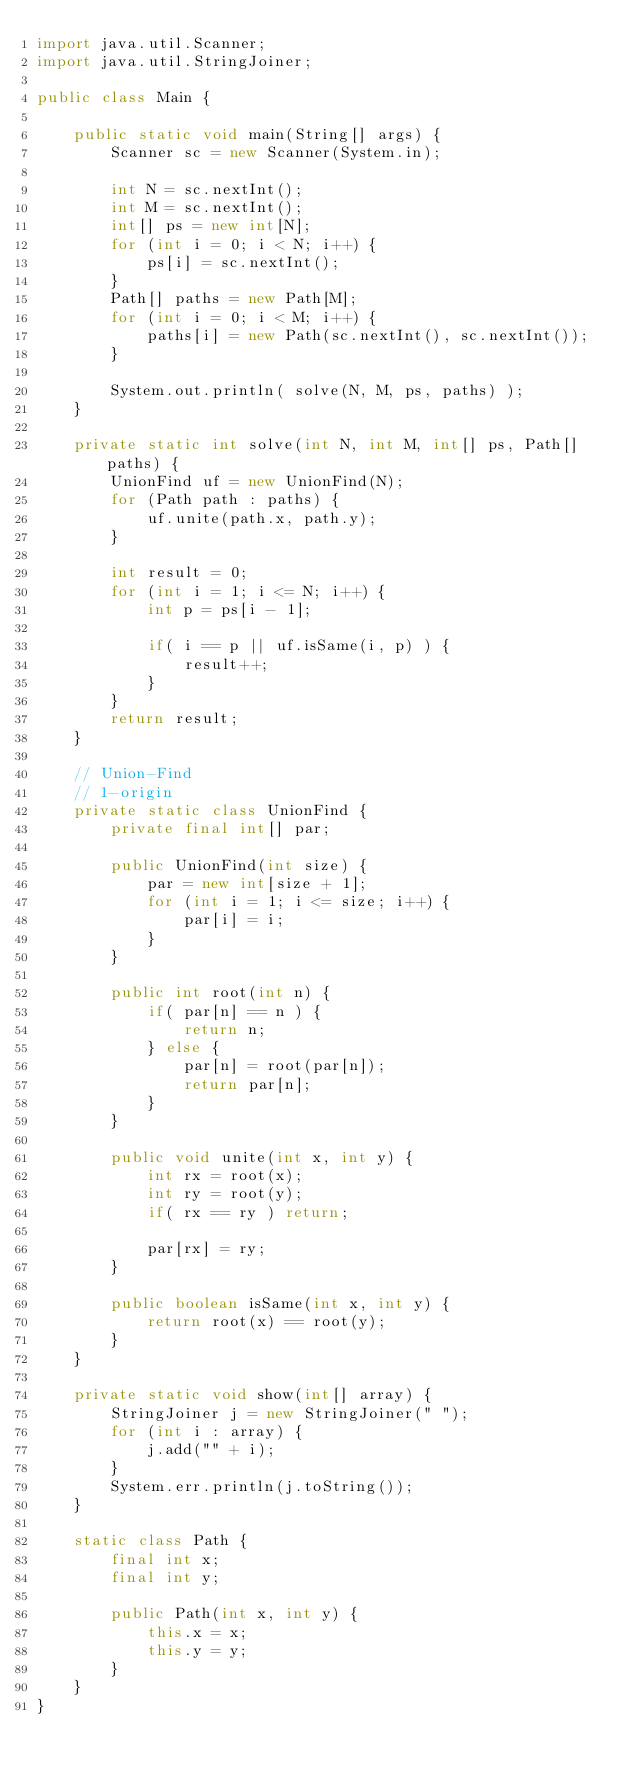<code> <loc_0><loc_0><loc_500><loc_500><_Java_>import java.util.Scanner;
import java.util.StringJoiner;

public class Main {

    public static void main(String[] args) {
        Scanner sc = new Scanner(System.in);

        int N = sc.nextInt();
        int M = sc.nextInt();
        int[] ps = new int[N];
        for (int i = 0; i < N; i++) {
            ps[i] = sc.nextInt();
        }
        Path[] paths = new Path[M];
        for (int i = 0; i < M; i++) {
            paths[i] = new Path(sc.nextInt(), sc.nextInt());
        }

        System.out.println( solve(N, M, ps, paths) );
    }

    private static int solve(int N, int M, int[] ps, Path[] paths) {
        UnionFind uf = new UnionFind(N);
        for (Path path : paths) {
            uf.unite(path.x, path.y);
        }

        int result = 0;
        for (int i = 1; i <= N; i++) {
            int p = ps[i - 1];

            if( i == p || uf.isSame(i, p) ) {
                result++;
            }
        }
        return result;
    }

    // Union-Find
    // 1-origin
    private static class UnionFind {
        private final int[] par;

        public UnionFind(int size) {
            par = new int[size + 1];
            for (int i = 1; i <= size; i++) {
                par[i] = i;
            }
        }

        public int root(int n) {
            if( par[n] == n ) {
                return n;
            } else {
                par[n] = root(par[n]);
                return par[n];
            }
        }

        public void unite(int x, int y) {
            int rx = root(x);
            int ry = root(y);
            if( rx == ry ) return;

            par[rx] = ry;
        }

        public boolean isSame(int x, int y) {
            return root(x) == root(y);
        }
    }

    private static void show(int[] array) {
        StringJoiner j = new StringJoiner(" ");
        for (int i : array) {
            j.add("" + i);
        }
        System.err.println(j.toString());
    }

    static class Path {
        final int x;
        final int y;

        public Path(int x, int y) {
            this.x = x;
            this.y = y;
        }
    }
}
</code> 